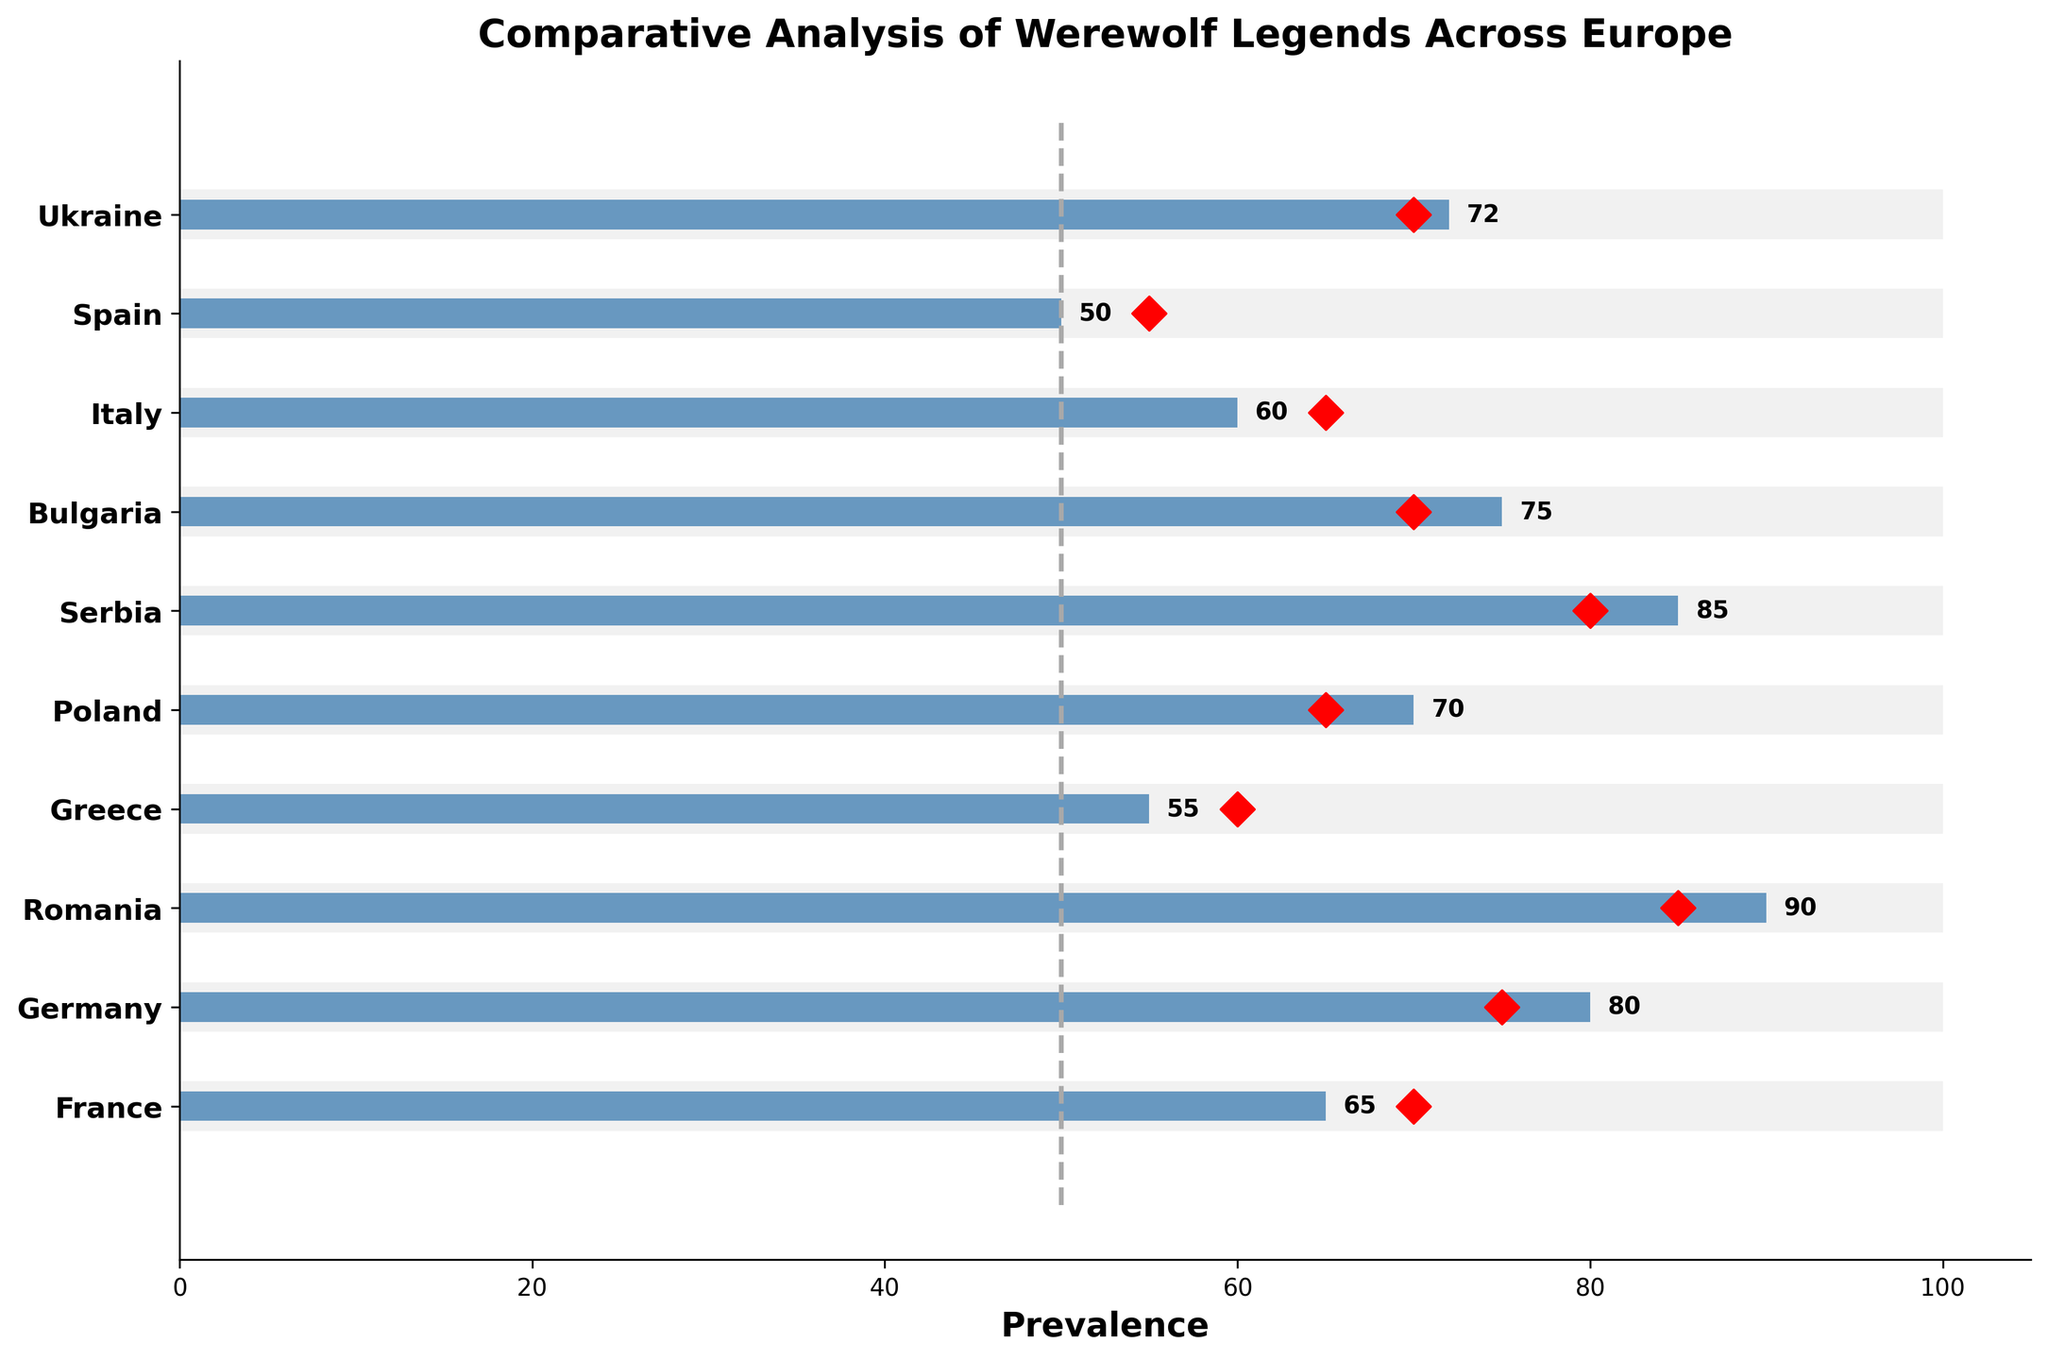Which country has the highest prevalence of werewolf legends? According to the figure, Romania has the highest prevalence with a value of 90.
Answer: Romania Which country has the lowest prevalence of werewolf legends? The figure shows that Spain has the lowest prevalence with a value of 50.
Answer: Spain What is the average prevalence value, marked by the vertical line? The vertical dashed line represents the average prevalence value, which is labeled as 50.
Answer: 50 Which countries have a prevalence value higher than their target? The countries with prevalence values higher than their targets are France, Romania, Serbia, Bulgaria, and Ukraine.
Answer: France, Romania, Serbia, Bulgaria, Ukraine Which country is closest to meeting its target prevalence? Italy is closest to meeting its target, with its prevalence at 60 and its target at 65, a difference of 5.
Answer: Italy How many countries have a prevalence value higher than the average? Analyzing the figure, the countries with values above the average (50) are France, Germany, Romania, Greece, Poland, Serbia, Bulgaria, Italy, and Ukraine, totaling 9 countries.
Answer: 9 countries What is the difference in prevalence between Germany and Spain? Germany has a prevalence of 80, while Spain has a prevalence of 50. The difference is 80 - 50 = 30.
Answer: 30 Which countries have a prevalence within 10 units of their target values? Looking at the figure, the countries within 10 units of their target values are France, Romania, Greece, Poland, Bulgaria, Italy, and Ukraine.
Answer: France, Romania, Greece, Poland, Bulgaria, Italy, Ukraine Is the target value for Greece higher or lower than its actual prevalence? According to the figure, the target value for Greece is 60 and its actual prevalence is 55, so the target is higher.
Answer: Higher What percentage of the countries have a prevalence value greater than or equal to 70? Out of 10 countries, those with prevalence values ≥70 are Germany, Romania, Poland, Serbia, Bulgaria, and Ukraine (6 countries). The percentage is (6/10)*100 = 60%.
Answer: 60% 